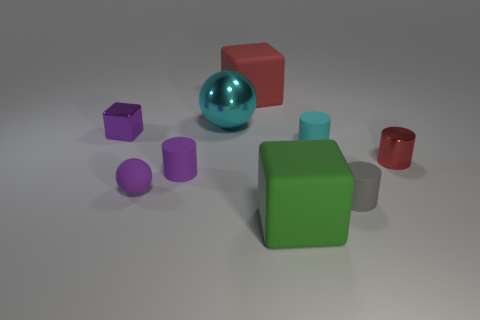What number of things are on the right side of the cyan sphere and behind the small cube?
Your answer should be compact. 1. There is a cyan thing that is the same size as the red cylinder; what shape is it?
Provide a succinct answer. Cylinder. Is there a tiny purple thing behind the red thing that is in front of the cyan object on the left side of the cyan matte cylinder?
Your response must be concise. Yes. There is a big ball; is it the same color as the rubber cylinder behind the tiny purple cylinder?
Give a very brief answer. Yes. What number of small cylinders are the same color as the big shiny thing?
Make the answer very short. 1. How big is the matte cylinder that is on the left side of the big block that is in front of the big red matte block?
Keep it short and to the point. Small. How many things are tiny objects that are in front of the red metal cylinder or blocks?
Provide a short and direct response. 6. Are there any purple cylinders of the same size as the purple shiny cube?
Offer a terse response. Yes. There is a big thing that is on the left side of the big red block; is there a block in front of it?
Your response must be concise. Yes. What number of cylinders are small yellow things or big cyan metallic things?
Provide a short and direct response. 0. 